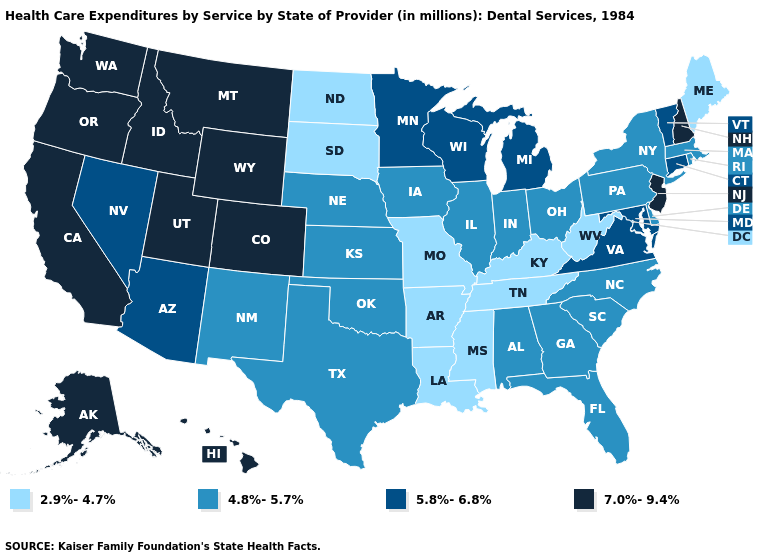What is the lowest value in states that border Ohio?
Keep it brief. 2.9%-4.7%. Name the states that have a value in the range 4.8%-5.7%?
Short answer required. Alabama, Delaware, Florida, Georgia, Illinois, Indiana, Iowa, Kansas, Massachusetts, Nebraska, New Mexico, New York, North Carolina, Ohio, Oklahoma, Pennsylvania, Rhode Island, South Carolina, Texas. Among the states that border Utah , which have the highest value?
Keep it brief. Colorado, Idaho, Wyoming. Does Texas have the highest value in the South?
Short answer required. No. What is the value of Michigan?
Short answer required. 5.8%-6.8%. Name the states that have a value in the range 4.8%-5.7%?
Concise answer only. Alabama, Delaware, Florida, Georgia, Illinois, Indiana, Iowa, Kansas, Massachusetts, Nebraska, New Mexico, New York, North Carolina, Ohio, Oklahoma, Pennsylvania, Rhode Island, South Carolina, Texas. Name the states that have a value in the range 2.9%-4.7%?
Keep it brief. Arkansas, Kentucky, Louisiana, Maine, Mississippi, Missouri, North Dakota, South Dakota, Tennessee, West Virginia. How many symbols are there in the legend?
Be succinct. 4. What is the lowest value in states that border North Dakota?
Keep it brief. 2.9%-4.7%. Name the states that have a value in the range 7.0%-9.4%?
Quick response, please. Alaska, California, Colorado, Hawaii, Idaho, Montana, New Hampshire, New Jersey, Oregon, Utah, Washington, Wyoming. Does New Jersey have a higher value than New Hampshire?
Be succinct. No. Name the states that have a value in the range 5.8%-6.8%?
Answer briefly. Arizona, Connecticut, Maryland, Michigan, Minnesota, Nevada, Vermont, Virginia, Wisconsin. What is the highest value in the USA?
Write a very short answer. 7.0%-9.4%. What is the lowest value in the Northeast?
Write a very short answer. 2.9%-4.7%. Which states hav the highest value in the South?
Concise answer only. Maryland, Virginia. 